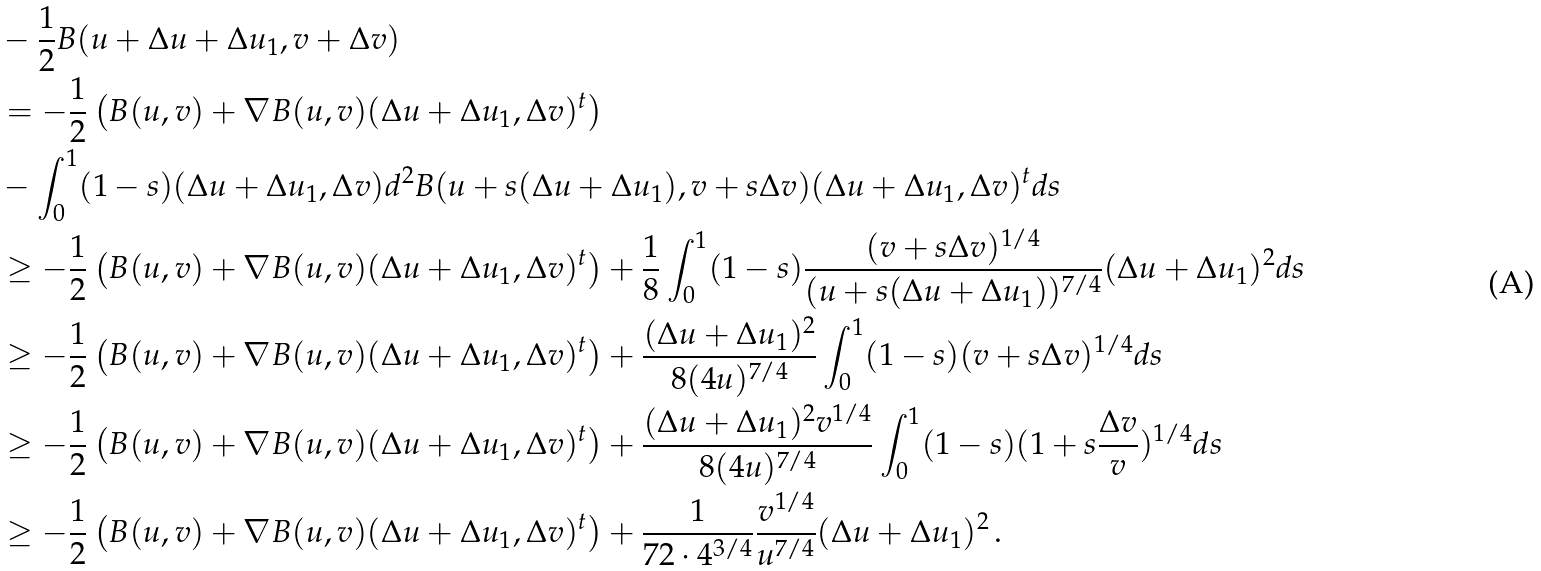<formula> <loc_0><loc_0><loc_500><loc_500>& - \frac { 1 } { 2 } B ( u + \Delta u + \Delta u _ { 1 } , v + \Delta v ) \\ & = - \frac { 1 } { 2 } \left ( B ( u , v ) + \nabla B ( u , v ) ( \Delta u + \Delta u _ { 1 } , \Delta v ) ^ { t } \right ) \\ & - \int ^ { 1 } _ { 0 } ( 1 - s ) ( \Delta u + \Delta u _ { 1 } , \Delta v ) d ^ { 2 } B ( u + s ( \Delta u + \Delta u _ { 1 } ) , v + s \Delta v ) ( \Delta u + \Delta u _ { 1 } , \Delta v ) ^ { t } d s \\ & \geq - \frac { 1 } { 2 } \left ( B ( u , v ) + \nabla B ( u , v ) ( \Delta u + \Delta u _ { 1 } , \Delta v ) ^ { t } \right ) + \frac { 1 } { 8 } \int ^ { 1 } _ { 0 } ( 1 - s ) \frac { ( v + s \Delta v ) ^ { 1 / 4 } } { ( u + s ( \Delta u + \Delta u _ { 1 } ) ) ^ { 7 / 4 } } ( \Delta u + \Delta u _ { 1 } ) ^ { 2 } d s \\ & \geq - \frac { 1 } { 2 } \left ( B ( u , v ) + \nabla B ( u , v ) ( \Delta u + \Delta u _ { 1 } , \Delta v ) ^ { t } \right ) + \frac { ( \Delta u + \Delta u _ { 1 } ) ^ { 2 } } { 8 ( 4 u ) ^ { 7 / 4 } } \int ^ { 1 } _ { 0 } ( 1 - s ) ( v + s \Delta v ) ^ { 1 / 4 } d s \\ & \geq - \frac { 1 } { 2 } \left ( B ( u , v ) + \nabla B ( u , v ) ( \Delta u + \Delta u _ { 1 } , \Delta v ) ^ { t } \right ) + \frac { ( \Delta u + \Delta u _ { 1 } ) ^ { 2 } v ^ { 1 / 4 } } { 8 ( 4 u ) ^ { 7 / 4 } } \int ^ { 1 } _ { 0 } ( 1 - s ) ( 1 + s \frac { \Delta v } { v } ) ^ { 1 / 4 } d s \\ & \geq - \frac { 1 } { 2 } \left ( B ( u , v ) + \nabla B ( u , v ) ( \Delta u + \Delta u _ { 1 } , \Delta v ) ^ { t } \right ) + \frac { 1 } { 7 2 \cdot 4 ^ { 3 / 4 } } \frac { v ^ { 1 / 4 } } { u ^ { 7 / 4 } } ( \Delta u + \Delta u _ { 1 } ) ^ { 2 } \, .</formula> 